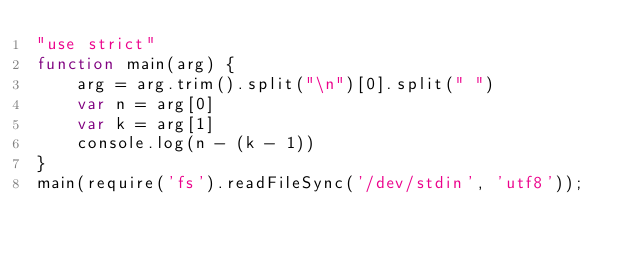<code> <loc_0><loc_0><loc_500><loc_500><_JavaScript_>"use strict"
function main(arg) {
    arg = arg.trim().split("\n")[0].split(" ")
    var n = arg[0]
    var k = arg[1]
    console.log(n - (k - 1))
}
main(require('fs').readFileSync('/dev/stdin', 'utf8'));</code> 